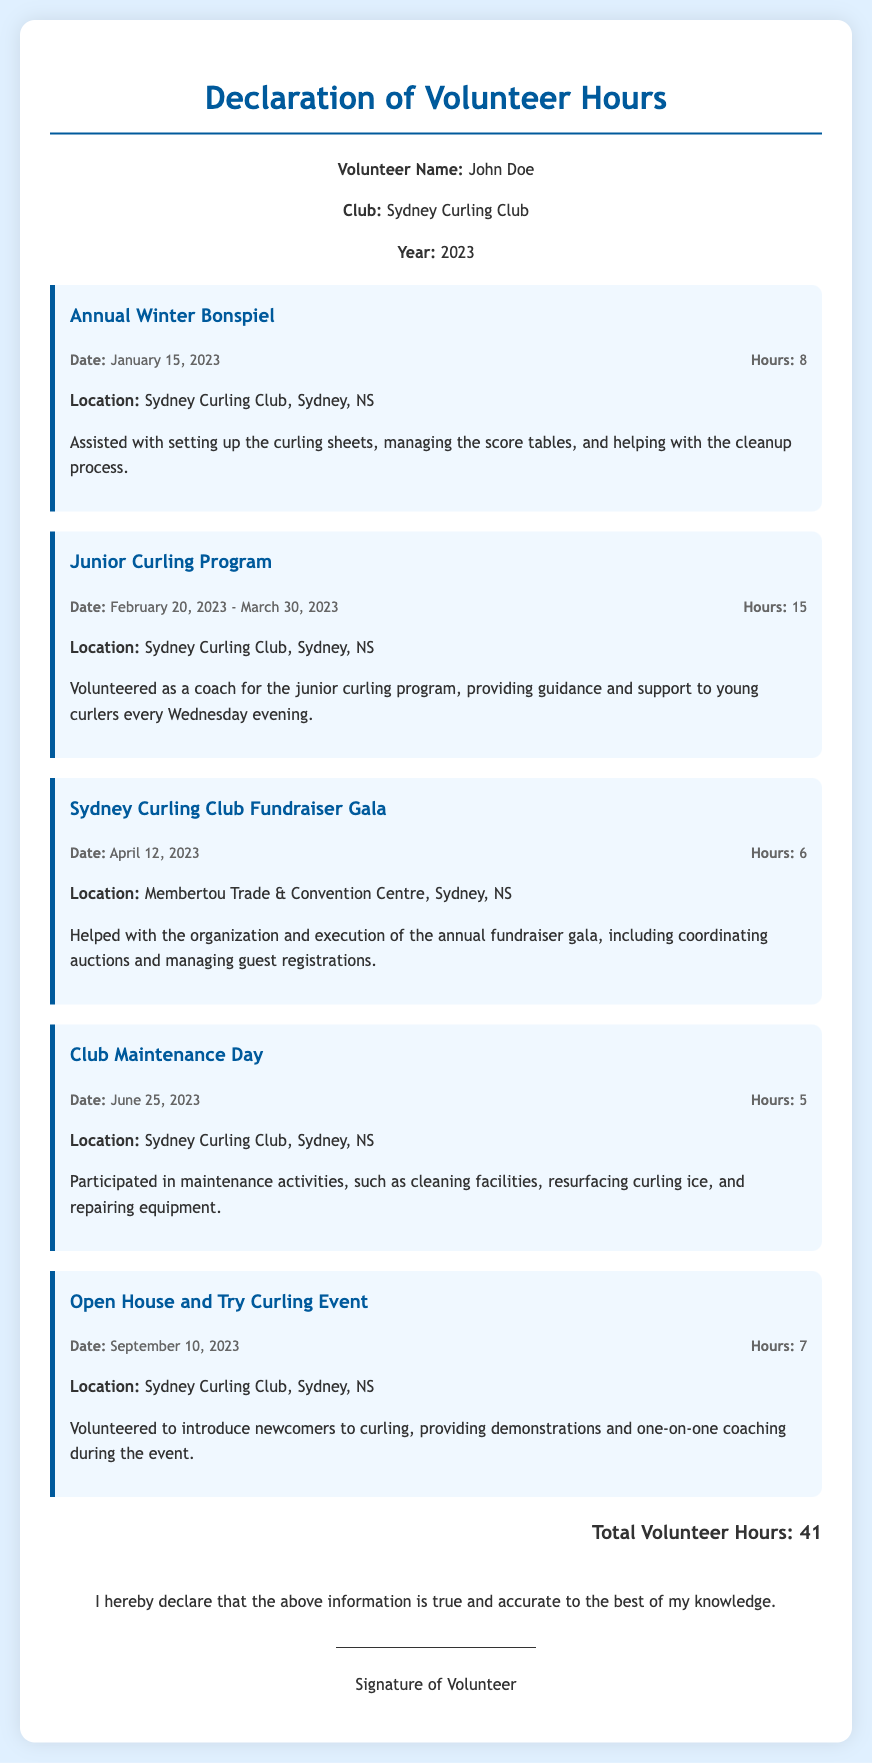What is the volunteer's name? The volunteer's name is provided in the header information of the document.
Answer: John Doe What is the total number of volunteer hours? The total number of volunteer hours is summed up and presented at the end of the document.
Answer: 41 When did the Annual Winter Bonspiel take place? The date of the Annual Winter Bonspiel is stated within the event details.
Answer: January 15, 2023 Where was the Sydney Curling Club Fundraiser Gala held? The location of the fundraiser gala is specified in the details of the event.
Answer: Membertou Trade & Convention Centre, Sydney, NS How many hours were contributed to the Junior Curling Program? The number of hours for the Junior Curling Program is mentioned alongside the event description.
Answer: 15 What activities did the volunteer assist with during the Open House and Try Curling Event? The specific activities of the Open House event are outlined in the description of that event.
Answer: Introducing newcomers to curling Which event had the least number of volunteer hours? To find the event with the least hours, we can compare the hours listed for each event in the document.
Answer: Club Maintenance Day What is the significance of the signature line? The signature line indicates the affirmation of the information's accuracy provided by the volunteer.
Answer: Signature of Volunteer 